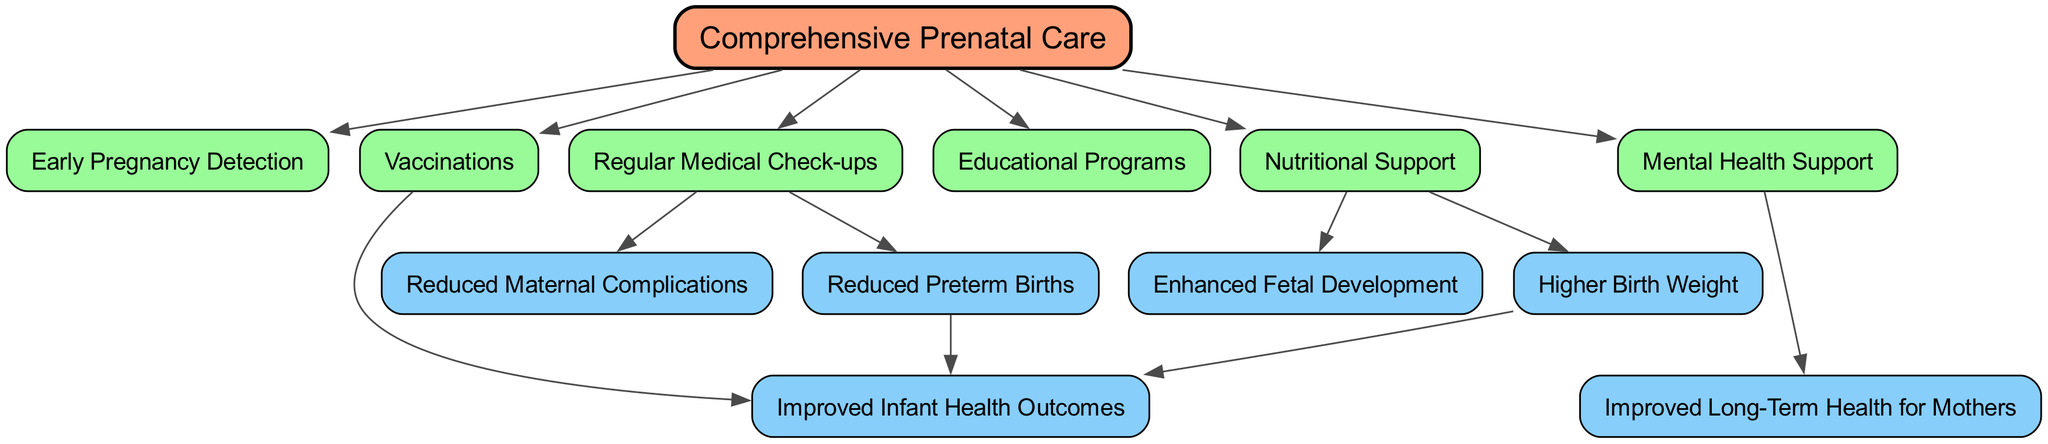What is the main focus of the diagram? The diagram centers around "Comprehensive Prenatal Care" as the starting point, from which various associated benefits and processes branch out.
Answer: Comprehensive Prenatal Care How many nodes are present in the diagram? By counting all distinct nodes listed, we find there are 13 nodes in total that represent various elements related to prenatal care and its impacts.
Answer: 13 What type of support is provided for mental health? The diagram specifies "Mental Health Support" as a benefit of comprehensive prenatal care, indicating that prenatal care incorporates this aspect.
Answer: Mental Health Support Which node connects "Regular Medical Check-ups" to "Reduced Maternal Complications"? The flow from "Regular Medical Check-ups" points directly to "Reduced Maternal Complications," showing a direct benefit from that action.
Answer: Reduced Maternal Complications What is one benefit of "Nutritional Support" according to the diagram? The diagram shows that "Nutritional Support" leads to "Enhanced Fetal Development," representing a significant benefit for fetal health.
Answer: Enhanced Fetal Development Which node connects both "Higher Birth Weight" and "Improved Infant Health Outcomes"? The node "Higher Birth Weight" directly connects to "Improved Infant Health Outcomes," indicating that increased birth weight positively influences infant health.
Answer: Improved Infant Health Outcomes What two benefits result from "Early Pregnancy Detection"? The flowchart indicates that "Early Pregnancy Detection" leads to "Reduced Maternal Complications" and "Reduced Preterm Births," showcasing its positive impact.
Answer: Reduced Maternal Complications and Reduced Preterm Births How does "Vaccinations" affect infants according to the diagram? "Vaccinations" lead directly to "Improved Infant Health Outcomes," emphasizing the critical role of vaccinations in ensuring better health for infants.
Answer: Improved Infant Health Outcomes What is the end outcome related to "Improved Long-Term Health for Mothers"? "Improved Long-Term Health for Mothers" is a direct result of "Mental Health Support," showing the comprehensive care's long-term benefits.
Answer: Improved Long-Term Health for Mothers 